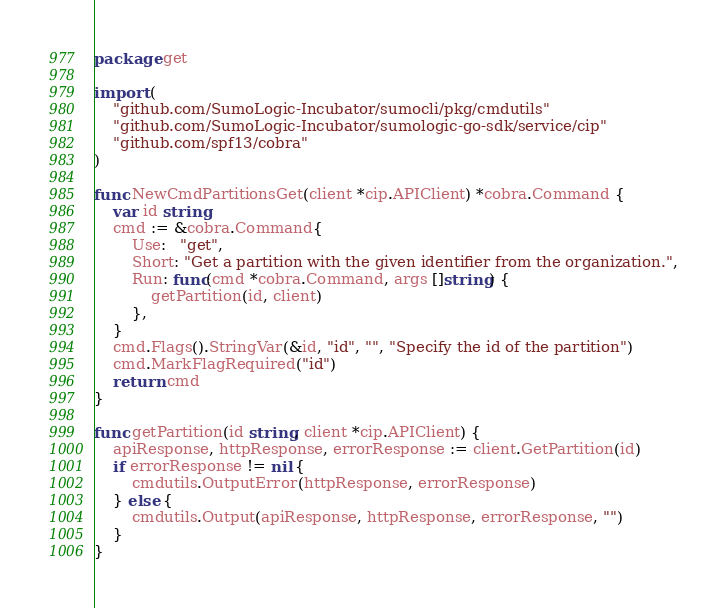<code> <loc_0><loc_0><loc_500><loc_500><_Go_>package get

import (
	"github.com/SumoLogic-Incubator/sumocli/pkg/cmdutils"
	"github.com/SumoLogic-Incubator/sumologic-go-sdk/service/cip"
	"github.com/spf13/cobra"
)

func NewCmdPartitionsGet(client *cip.APIClient) *cobra.Command {
	var id string
	cmd := &cobra.Command{
		Use:   "get",
		Short: "Get a partition with the given identifier from the organization.",
		Run: func(cmd *cobra.Command, args []string) {
			getPartition(id, client)
		},
	}
	cmd.Flags().StringVar(&id, "id", "", "Specify the id of the partition")
	cmd.MarkFlagRequired("id")
	return cmd
}

func getPartition(id string, client *cip.APIClient) {
	apiResponse, httpResponse, errorResponse := client.GetPartition(id)
	if errorResponse != nil {
		cmdutils.OutputError(httpResponse, errorResponse)
	} else {
		cmdutils.Output(apiResponse, httpResponse, errorResponse, "")
	}
}
</code> 